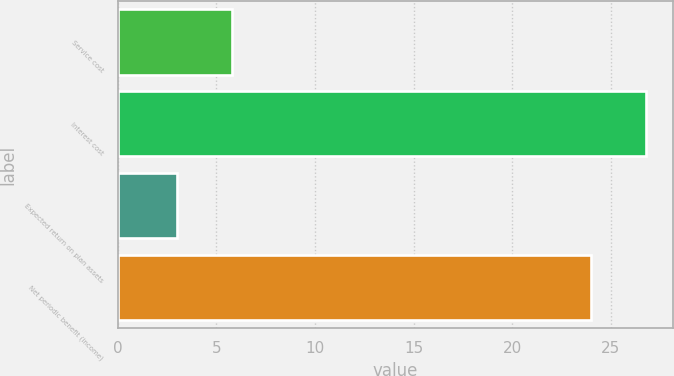<chart> <loc_0><loc_0><loc_500><loc_500><bar_chart><fcel>Service cost<fcel>Interest cost<fcel>Expected return on plan assets<fcel>Net periodic benefit (income)<nl><fcel>5.8<fcel>26.8<fcel>3<fcel>24<nl></chart> 